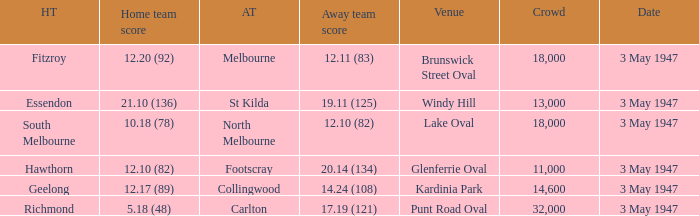Which venue did the away team score 12.10 (82)? Lake Oval. 